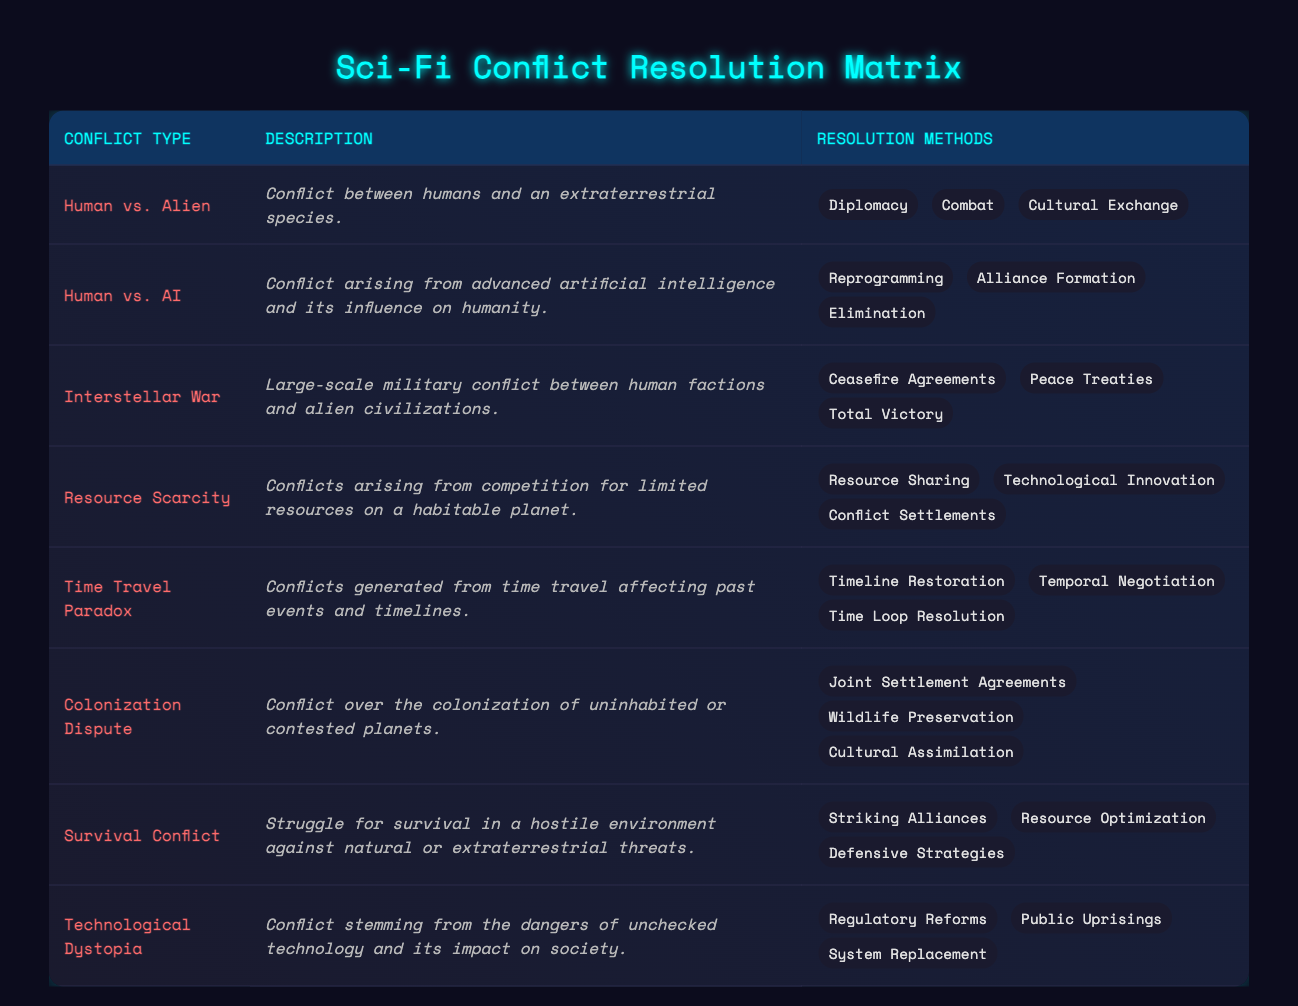What is the resolution method for Human vs. Alien conflict? The table indicates that the resolution methods for the Human vs. Alien conflict include "Diplomacy," "Combat," and "Cultural Exchange." Thus, any of these can be considered valid answers for this specific conflict type.
Answer: Diplomacy, Combat, Cultural Exchange Which conflict type involves advanced artificial intelligence? By examining the table, we find that the conflict type categorized as "Human vs. AI" specifically addresses situations arising from advanced artificial intelligence and its influence on humanity.
Answer: Human vs. AI How many resolution methods are listed for the Interstellar War? The table shows that the Interstellar War conflict has three resolution methods: "Ceasefire Agreements," "Peace Treaties," and "Total Victory." Therefore, the number of resolution methods here is three.
Answer: 3 Is Resource Scarcity resolved by Technological Innovation? The table states that one of the resolution methods for Resource Scarcity is indeed "Technological Innovation," indicating that this method is valid for addressing that type of conflict.
Answer: Yes Which conflict types have "Cultural Assimilation" as a resolution method? Looking at the table, "Cultural Assimilation" is listed solely under the "Colonization Dispute" conflict type. This indicates that Cultural Assimilation is exclusive to this specific situation.
Answer: Colonization Dispute What is the sum of the number of resolution methods for Human vs. Alien and Human vs. AI? The Human vs. Alien conflict has three resolution methods, while the Human vs. AI conflict also lists three resolution methods. By adding these two numbers (3 + 3), we determine the total number of resolution methods across these conflicts.
Answer: 6 How many conflicts involve struggles for survival or resource competition? The table indicates that there are two relevant conflicts: "Survival Conflict," which discusses struggles for survival in hostile conditions, and "Resource Scarcity," which pertains to competition for limited resources. Thus, the total number of conflicts described is two.
Answer: 2 Which conflict types can be resolved through Ceasefire Agreements? Upon reviewing the table, we see that "Interstellar War" is the only conflict type that mentions "Ceasefire Agreements" as a resolution method. Hence, it is the sole conflict type associated with this resolution.
Answer: Interstellar War Can Time Travel Paradox be resolved with Cultural Exchange? The table lists "Timeline Restoration," "Temporal Negotiation," and "Time Loop Resolution" as possible methods for resolving the Time Travel Paradox, but it does not include Cultural Exchange as a resolution method. Therefore, this resolution is not applicable.
Answer: No 